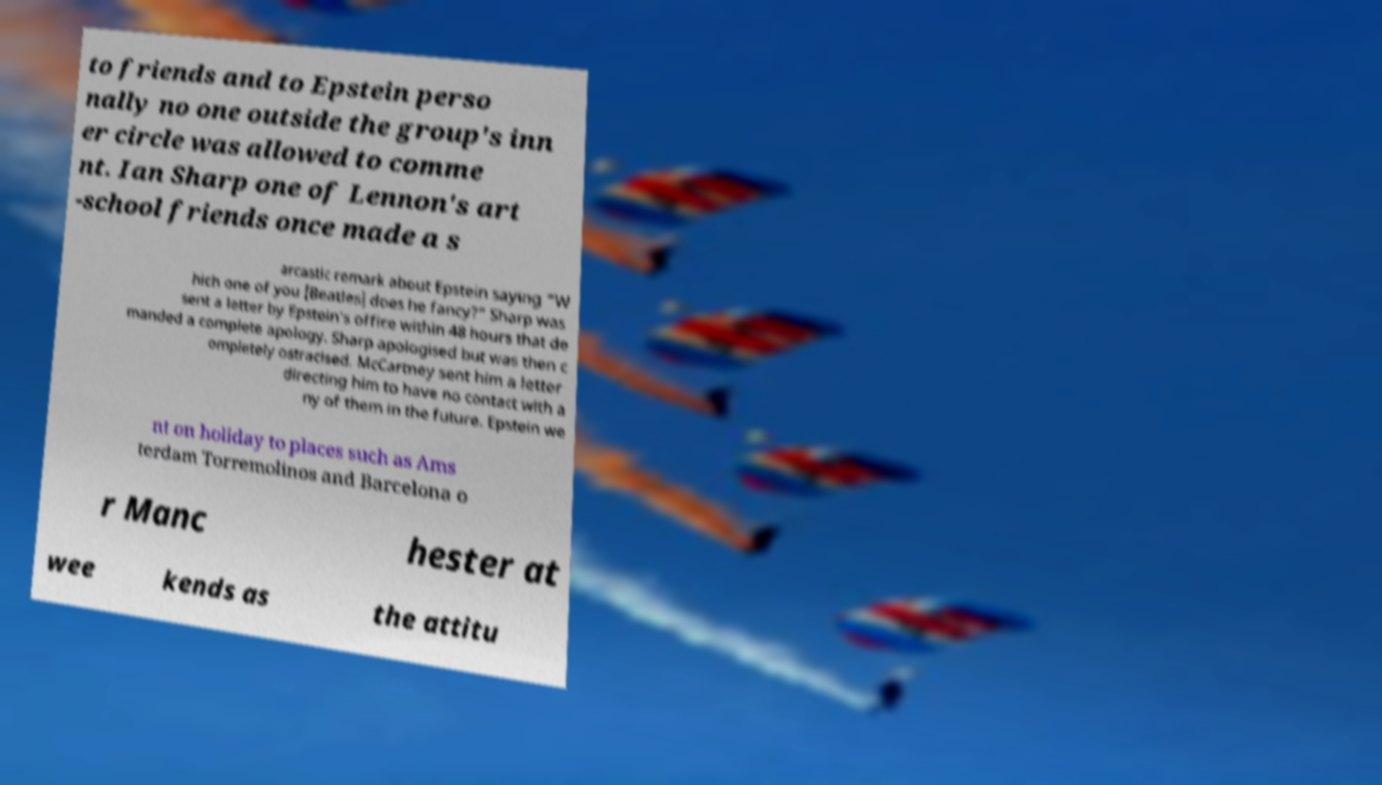Can you accurately transcribe the text from the provided image for me? to friends and to Epstein perso nally no one outside the group's inn er circle was allowed to comme nt. Ian Sharp one of Lennon's art -school friends once made a s arcastic remark about Epstein saying "W hich one of you [Beatles] does he fancy?" Sharp was sent a letter by Epstein's office within 48 hours that de manded a complete apology. Sharp apologised but was then c ompletely ostracised. McCartney sent him a letter directing him to have no contact with a ny of them in the future. Epstein we nt on holiday to places such as Ams terdam Torremolinos and Barcelona o r Manc hester at wee kends as the attitu 